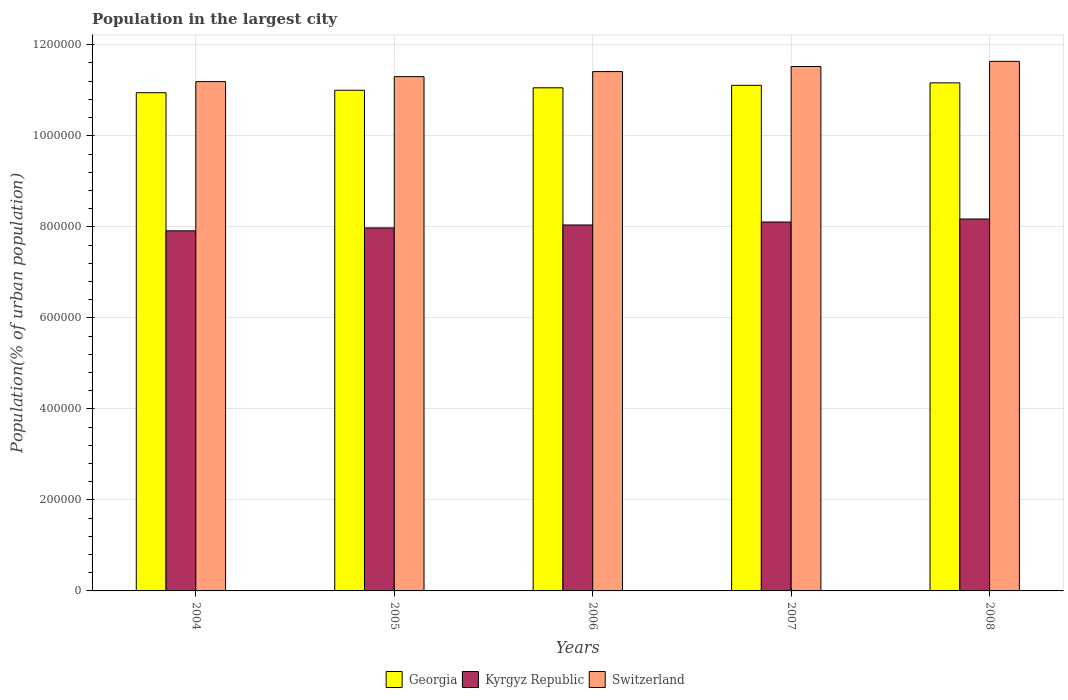How many groups of bars are there?
Keep it short and to the point. 5. Are the number of bars on each tick of the X-axis equal?
Your answer should be very brief. Yes. What is the population in the largest city in Georgia in 2006?
Offer a terse response. 1.11e+06. Across all years, what is the maximum population in the largest city in Switzerland?
Make the answer very short. 1.16e+06. Across all years, what is the minimum population in the largest city in Switzerland?
Offer a very short reply. 1.12e+06. What is the total population in the largest city in Georgia in the graph?
Offer a terse response. 5.53e+06. What is the difference between the population in the largest city in Kyrgyz Republic in 2004 and that in 2006?
Offer a terse response. -1.29e+04. What is the difference between the population in the largest city in Switzerland in 2007 and the population in the largest city in Kyrgyz Republic in 2005?
Your answer should be compact. 3.55e+05. What is the average population in the largest city in Switzerland per year?
Ensure brevity in your answer.  1.14e+06. In the year 2008, what is the difference between the population in the largest city in Kyrgyz Republic and population in the largest city in Switzerland?
Your answer should be very brief. -3.46e+05. In how many years, is the population in the largest city in Kyrgyz Republic greater than 1160000 %?
Keep it short and to the point. 0. What is the ratio of the population in the largest city in Georgia in 2004 to that in 2008?
Ensure brevity in your answer.  0.98. What is the difference between the highest and the second highest population in the largest city in Kyrgyz Republic?
Keep it short and to the point. 6585. What is the difference between the highest and the lowest population in the largest city in Kyrgyz Republic?
Your response must be concise. 2.60e+04. In how many years, is the population in the largest city in Georgia greater than the average population in the largest city in Georgia taken over all years?
Your answer should be compact. 2. Is the sum of the population in the largest city in Georgia in 2004 and 2008 greater than the maximum population in the largest city in Kyrgyz Republic across all years?
Give a very brief answer. Yes. What does the 3rd bar from the left in 2008 represents?
Provide a short and direct response. Switzerland. What does the 1st bar from the right in 2005 represents?
Keep it short and to the point. Switzerland. How many bars are there?
Your response must be concise. 15. Does the graph contain any zero values?
Make the answer very short. No. Where does the legend appear in the graph?
Give a very brief answer. Bottom center. How many legend labels are there?
Ensure brevity in your answer.  3. How are the legend labels stacked?
Make the answer very short. Horizontal. What is the title of the graph?
Make the answer very short. Population in the largest city. Does "Spain" appear as one of the legend labels in the graph?
Ensure brevity in your answer.  No. What is the label or title of the X-axis?
Provide a short and direct response. Years. What is the label or title of the Y-axis?
Your response must be concise. Population(% of urban population). What is the Population(% of urban population) of Georgia in 2004?
Make the answer very short. 1.09e+06. What is the Population(% of urban population) of Kyrgyz Republic in 2004?
Make the answer very short. 7.91e+05. What is the Population(% of urban population) in Switzerland in 2004?
Offer a very short reply. 1.12e+06. What is the Population(% of urban population) of Georgia in 2005?
Ensure brevity in your answer.  1.10e+06. What is the Population(% of urban population) in Kyrgyz Republic in 2005?
Make the answer very short. 7.98e+05. What is the Population(% of urban population) in Switzerland in 2005?
Ensure brevity in your answer.  1.13e+06. What is the Population(% of urban population) in Georgia in 2006?
Keep it short and to the point. 1.11e+06. What is the Population(% of urban population) in Kyrgyz Republic in 2006?
Offer a very short reply. 8.04e+05. What is the Population(% of urban population) in Switzerland in 2006?
Your response must be concise. 1.14e+06. What is the Population(% of urban population) of Georgia in 2007?
Your response must be concise. 1.11e+06. What is the Population(% of urban population) in Kyrgyz Republic in 2007?
Make the answer very short. 8.11e+05. What is the Population(% of urban population) of Switzerland in 2007?
Make the answer very short. 1.15e+06. What is the Population(% of urban population) in Georgia in 2008?
Keep it short and to the point. 1.12e+06. What is the Population(% of urban population) in Kyrgyz Republic in 2008?
Give a very brief answer. 8.17e+05. What is the Population(% of urban population) of Switzerland in 2008?
Offer a terse response. 1.16e+06. Across all years, what is the maximum Population(% of urban population) in Georgia?
Make the answer very short. 1.12e+06. Across all years, what is the maximum Population(% of urban population) of Kyrgyz Republic?
Your answer should be compact. 8.17e+05. Across all years, what is the maximum Population(% of urban population) of Switzerland?
Ensure brevity in your answer.  1.16e+06. Across all years, what is the minimum Population(% of urban population) in Georgia?
Your answer should be very brief. 1.09e+06. Across all years, what is the minimum Population(% of urban population) in Kyrgyz Republic?
Ensure brevity in your answer.  7.91e+05. Across all years, what is the minimum Population(% of urban population) of Switzerland?
Ensure brevity in your answer.  1.12e+06. What is the total Population(% of urban population) in Georgia in the graph?
Keep it short and to the point. 5.53e+06. What is the total Population(% of urban population) of Kyrgyz Republic in the graph?
Offer a very short reply. 4.02e+06. What is the total Population(% of urban population) in Switzerland in the graph?
Make the answer very short. 5.71e+06. What is the difference between the Population(% of urban population) of Georgia in 2004 and that in 2005?
Your response must be concise. -5362. What is the difference between the Population(% of urban population) in Kyrgyz Republic in 2004 and that in 2005?
Keep it short and to the point. -6409. What is the difference between the Population(% of urban population) in Switzerland in 2004 and that in 2005?
Your answer should be very brief. -1.10e+04. What is the difference between the Population(% of urban population) in Georgia in 2004 and that in 2006?
Offer a terse response. -1.08e+04. What is the difference between the Population(% of urban population) in Kyrgyz Republic in 2004 and that in 2006?
Your answer should be compact. -1.29e+04. What is the difference between the Population(% of urban population) in Switzerland in 2004 and that in 2006?
Your answer should be compact. -2.20e+04. What is the difference between the Population(% of urban population) in Georgia in 2004 and that in 2007?
Ensure brevity in your answer.  -1.62e+04. What is the difference between the Population(% of urban population) in Kyrgyz Republic in 2004 and that in 2007?
Offer a very short reply. -1.94e+04. What is the difference between the Population(% of urban population) of Switzerland in 2004 and that in 2007?
Your answer should be very brief. -3.32e+04. What is the difference between the Population(% of urban population) in Georgia in 2004 and that in 2008?
Give a very brief answer. -2.16e+04. What is the difference between the Population(% of urban population) in Kyrgyz Republic in 2004 and that in 2008?
Make the answer very short. -2.60e+04. What is the difference between the Population(% of urban population) in Switzerland in 2004 and that in 2008?
Provide a succinct answer. -4.45e+04. What is the difference between the Population(% of urban population) in Georgia in 2005 and that in 2006?
Your response must be concise. -5395. What is the difference between the Population(% of urban population) of Kyrgyz Republic in 2005 and that in 2006?
Make the answer very short. -6470. What is the difference between the Population(% of urban population) of Switzerland in 2005 and that in 2006?
Keep it short and to the point. -1.11e+04. What is the difference between the Population(% of urban population) in Georgia in 2005 and that in 2007?
Make the answer very short. -1.08e+04. What is the difference between the Population(% of urban population) of Kyrgyz Republic in 2005 and that in 2007?
Your response must be concise. -1.30e+04. What is the difference between the Population(% of urban population) of Switzerland in 2005 and that in 2007?
Provide a short and direct response. -2.23e+04. What is the difference between the Population(% of urban population) in Georgia in 2005 and that in 2008?
Offer a terse response. -1.63e+04. What is the difference between the Population(% of urban population) in Kyrgyz Republic in 2005 and that in 2008?
Ensure brevity in your answer.  -1.96e+04. What is the difference between the Population(% of urban population) in Switzerland in 2005 and that in 2008?
Your response must be concise. -3.36e+04. What is the difference between the Population(% of urban population) of Georgia in 2006 and that in 2007?
Offer a very short reply. -5422. What is the difference between the Population(% of urban population) in Kyrgyz Republic in 2006 and that in 2007?
Your answer should be very brief. -6522. What is the difference between the Population(% of urban population) in Switzerland in 2006 and that in 2007?
Make the answer very short. -1.12e+04. What is the difference between the Population(% of urban population) of Georgia in 2006 and that in 2008?
Ensure brevity in your answer.  -1.09e+04. What is the difference between the Population(% of urban population) of Kyrgyz Republic in 2006 and that in 2008?
Give a very brief answer. -1.31e+04. What is the difference between the Population(% of urban population) of Switzerland in 2006 and that in 2008?
Keep it short and to the point. -2.25e+04. What is the difference between the Population(% of urban population) in Georgia in 2007 and that in 2008?
Make the answer very short. -5456. What is the difference between the Population(% of urban population) in Kyrgyz Republic in 2007 and that in 2008?
Keep it short and to the point. -6585. What is the difference between the Population(% of urban population) of Switzerland in 2007 and that in 2008?
Your response must be concise. -1.13e+04. What is the difference between the Population(% of urban population) of Georgia in 2004 and the Population(% of urban population) of Kyrgyz Republic in 2005?
Provide a succinct answer. 2.97e+05. What is the difference between the Population(% of urban population) in Georgia in 2004 and the Population(% of urban population) in Switzerland in 2005?
Make the answer very short. -3.53e+04. What is the difference between the Population(% of urban population) in Kyrgyz Republic in 2004 and the Population(% of urban population) in Switzerland in 2005?
Your answer should be compact. -3.39e+05. What is the difference between the Population(% of urban population) of Georgia in 2004 and the Population(% of urban population) of Kyrgyz Republic in 2006?
Your response must be concise. 2.91e+05. What is the difference between the Population(% of urban population) of Georgia in 2004 and the Population(% of urban population) of Switzerland in 2006?
Your answer should be compact. -4.64e+04. What is the difference between the Population(% of urban population) of Kyrgyz Republic in 2004 and the Population(% of urban population) of Switzerland in 2006?
Offer a terse response. -3.50e+05. What is the difference between the Population(% of urban population) in Georgia in 2004 and the Population(% of urban population) in Kyrgyz Republic in 2007?
Provide a short and direct response. 2.84e+05. What is the difference between the Population(% of urban population) in Georgia in 2004 and the Population(% of urban population) in Switzerland in 2007?
Make the answer very short. -5.76e+04. What is the difference between the Population(% of urban population) of Kyrgyz Republic in 2004 and the Population(% of urban population) of Switzerland in 2007?
Your response must be concise. -3.61e+05. What is the difference between the Population(% of urban population) of Georgia in 2004 and the Population(% of urban population) of Kyrgyz Republic in 2008?
Give a very brief answer. 2.78e+05. What is the difference between the Population(% of urban population) in Georgia in 2004 and the Population(% of urban population) in Switzerland in 2008?
Offer a terse response. -6.89e+04. What is the difference between the Population(% of urban population) of Kyrgyz Republic in 2004 and the Population(% of urban population) of Switzerland in 2008?
Make the answer very short. -3.72e+05. What is the difference between the Population(% of urban population) of Georgia in 2005 and the Population(% of urban population) of Kyrgyz Republic in 2006?
Offer a very short reply. 2.96e+05. What is the difference between the Population(% of urban population) in Georgia in 2005 and the Population(% of urban population) in Switzerland in 2006?
Ensure brevity in your answer.  -4.10e+04. What is the difference between the Population(% of urban population) in Kyrgyz Republic in 2005 and the Population(% of urban population) in Switzerland in 2006?
Make the answer very short. -3.43e+05. What is the difference between the Population(% of urban population) of Georgia in 2005 and the Population(% of urban population) of Kyrgyz Republic in 2007?
Give a very brief answer. 2.89e+05. What is the difference between the Population(% of urban population) in Georgia in 2005 and the Population(% of urban population) in Switzerland in 2007?
Ensure brevity in your answer.  -5.22e+04. What is the difference between the Population(% of urban population) in Kyrgyz Republic in 2005 and the Population(% of urban population) in Switzerland in 2007?
Your answer should be very brief. -3.55e+05. What is the difference between the Population(% of urban population) in Georgia in 2005 and the Population(% of urban population) in Kyrgyz Republic in 2008?
Offer a terse response. 2.83e+05. What is the difference between the Population(% of urban population) in Georgia in 2005 and the Population(% of urban population) in Switzerland in 2008?
Offer a terse response. -6.35e+04. What is the difference between the Population(% of urban population) in Kyrgyz Republic in 2005 and the Population(% of urban population) in Switzerland in 2008?
Offer a very short reply. -3.66e+05. What is the difference between the Population(% of urban population) of Georgia in 2006 and the Population(% of urban population) of Kyrgyz Republic in 2007?
Your answer should be compact. 2.95e+05. What is the difference between the Population(% of urban population) in Georgia in 2006 and the Population(% of urban population) in Switzerland in 2007?
Your response must be concise. -4.68e+04. What is the difference between the Population(% of urban population) in Kyrgyz Republic in 2006 and the Population(% of urban population) in Switzerland in 2007?
Give a very brief answer. -3.48e+05. What is the difference between the Population(% of urban population) of Georgia in 2006 and the Population(% of urban population) of Kyrgyz Republic in 2008?
Give a very brief answer. 2.88e+05. What is the difference between the Population(% of urban population) of Georgia in 2006 and the Population(% of urban population) of Switzerland in 2008?
Your answer should be compact. -5.81e+04. What is the difference between the Population(% of urban population) in Kyrgyz Republic in 2006 and the Population(% of urban population) in Switzerland in 2008?
Offer a terse response. -3.60e+05. What is the difference between the Population(% of urban population) of Georgia in 2007 and the Population(% of urban population) of Kyrgyz Republic in 2008?
Your answer should be compact. 2.94e+05. What is the difference between the Population(% of urban population) of Georgia in 2007 and the Population(% of urban population) of Switzerland in 2008?
Ensure brevity in your answer.  -5.27e+04. What is the difference between the Population(% of urban population) in Kyrgyz Republic in 2007 and the Population(% of urban population) in Switzerland in 2008?
Provide a succinct answer. -3.53e+05. What is the average Population(% of urban population) in Georgia per year?
Offer a terse response. 1.11e+06. What is the average Population(% of urban population) of Kyrgyz Republic per year?
Provide a short and direct response. 8.04e+05. What is the average Population(% of urban population) in Switzerland per year?
Your answer should be compact. 1.14e+06. In the year 2004, what is the difference between the Population(% of urban population) of Georgia and Population(% of urban population) of Kyrgyz Republic?
Keep it short and to the point. 3.04e+05. In the year 2004, what is the difference between the Population(% of urban population) of Georgia and Population(% of urban population) of Switzerland?
Ensure brevity in your answer.  -2.43e+04. In the year 2004, what is the difference between the Population(% of urban population) of Kyrgyz Republic and Population(% of urban population) of Switzerland?
Your answer should be compact. -3.28e+05. In the year 2005, what is the difference between the Population(% of urban population) in Georgia and Population(% of urban population) in Kyrgyz Republic?
Provide a short and direct response. 3.02e+05. In the year 2005, what is the difference between the Population(% of urban population) in Georgia and Population(% of urban population) in Switzerland?
Provide a short and direct response. -2.99e+04. In the year 2005, what is the difference between the Population(% of urban population) of Kyrgyz Republic and Population(% of urban population) of Switzerland?
Your response must be concise. -3.32e+05. In the year 2006, what is the difference between the Population(% of urban population) of Georgia and Population(% of urban population) of Kyrgyz Republic?
Provide a succinct answer. 3.01e+05. In the year 2006, what is the difference between the Population(% of urban population) in Georgia and Population(% of urban population) in Switzerland?
Give a very brief answer. -3.56e+04. In the year 2006, what is the difference between the Population(% of urban population) of Kyrgyz Republic and Population(% of urban population) of Switzerland?
Ensure brevity in your answer.  -3.37e+05. In the year 2007, what is the difference between the Population(% of urban population) of Georgia and Population(% of urban population) of Kyrgyz Republic?
Ensure brevity in your answer.  3.00e+05. In the year 2007, what is the difference between the Population(% of urban population) in Georgia and Population(% of urban population) in Switzerland?
Your answer should be compact. -4.14e+04. In the year 2007, what is the difference between the Population(% of urban population) in Kyrgyz Republic and Population(% of urban population) in Switzerland?
Keep it short and to the point. -3.42e+05. In the year 2008, what is the difference between the Population(% of urban population) in Georgia and Population(% of urban population) in Kyrgyz Republic?
Keep it short and to the point. 2.99e+05. In the year 2008, what is the difference between the Population(% of urban population) of Georgia and Population(% of urban population) of Switzerland?
Provide a short and direct response. -4.72e+04. In the year 2008, what is the difference between the Population(% of urban population) in Kyrgyz Republic and Population(% of urban population) in Switzerland?
Your answer should be very brief. -3.46e+05. What is the ratio of the Population(% of urban population) in Kyrgyz Republic in 2004 to that in 2005?
Make the answer very short. 0.99. What is the ratio of the Population(% of urban population) in Switzerland in 2004 to that in 2005?
Ensure brevity in your answer.  0.99. What is the ratio of the Population(% of urban population) in Georgia in 2004 to that in 2006?
Offer a very short reply. 0.99. What is the ratio of the Population(% of urban population) in Kyrgyz Republic in 2004 to that in 2006?
Keep it short and to the point. 0.98. What is the ratio of the Population(% of urban population) of Switzerland in 2004 to that in 2006?
Offer a terse response. 0.98. What is the ratio of the Population(% of urban population) of Georgia in 2004 to that in 2007?
Ensure brevity in your answer.  0.99. What is the ratio of the Population(% of urban population) of Kyrgyz Republic in 2004 to that in 2007?
Offer a very short reply. 0.98. What is the ratio of the Population(% of urban population) of Switzerland in 2004 to that in 2007?
Offer a very short reply. 0.97. What is the ratio of the Population(% of urban population) in Georgia in 2004 to that in 2008?
Your response must be concise. 0.98. What is the ratio of the Population(% of urban population) in Kyrgyz Republic in 2004 to that in 2008?
Give a very brief answer. 0.97. What is the ratio of the Population(% of urban population) in Switzerland in 2004 to that in 2008?
Keep it short and to the point. 0.96. What is the ratio of the Population(% of urban population) in Switzerland in 2005 to that in 2006?
Give a very brief answer. 0.99. What is the ratio of the Population(% of urban population) in Georgia in 2005 to that in 2007?
Provide a short and direct response. 0.99. What is the ratio of the Population(% of urban population) in Kyrgyz Republic in 2005 to that in 2007?
Provide a succinct answer. 0.98. What is the ratio of the Population(% of urban population) of Switzerland in 2005 to that in 2007?
Provide a short and direct response. 0.98. What is the ratio of the Population(% of urban population) of Georgia in 2005 to that in 2008?
Keep it short and to the point. 0.99. What is the ratio of the Population(% of urban population) of Switzerland in 2005 to that in 2008?
Your answer should be very brief. 0.97. What is the ratio of the Population(% of urban population) in Kyrgyz Republic in 2006 to that in 2007?
Your response must be concise. 0.99. What is the ratio of the Population(% of urban population) of Switzerland in 2006 to that in 2007?
Ensure brevity in your answer.  0.99. What is the ratio of the Population(% of urban population) of Georgia in 2006 to that in 2008?
Give a very brief answer. 0.99. What is the ratio of the Population(% of urban population) in Switzerland in 2006 to that in 2008?
Offer a very short reply. 0.98. What is the ratio of the Population(% of urban population) of Georgia in 2007 to that in 2008?
Provide a succinct answer. 1. What is the ratio of the Population(% of urban population) of Switzerland in 2007 to that in 2008?
Your answer should be very brief. 0.99. What is the difference between the highest and the second highest Population(% of urban population) of Georgia?
Give a very brief answer. 5456. What is the difference between the highest and the second highest Population(% of urban population) of Kyrgyz Republic?
Keep it short and to the point. 6585. What is the difference between the highest and the second highest Population(% of urban population) in Switzerland?
Make the answer very short. 1.13e+04. What is the difference between the highest and the lowest Population(% of urban population) in Georgia?
Give a very brief answer. 2.16e+04. What is the difference between the highest and the lowest Population(% of urban population) of Kyrgyz Republic?
Give a very brief answer. 2.60e+04. What is the difference between the highest and the lowest Population(% of urban population) of Switzerland?
Give a very brief answer. 4.45e+04. 